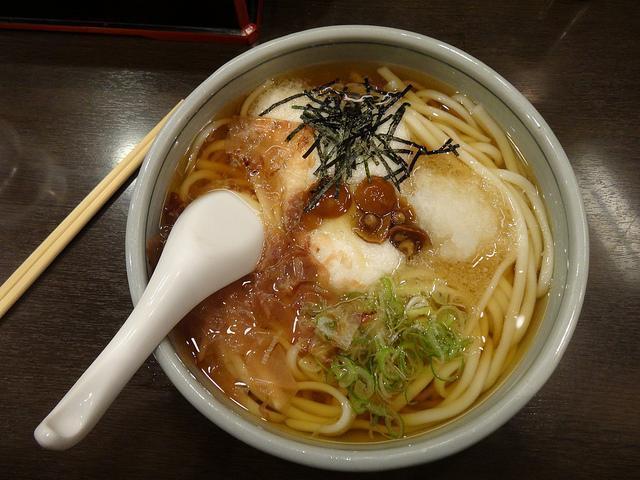What is the bowl made from?
Answer the question by selecting the correct answer among the 4 following choices and explain your choice with a short sentence. The answer should be formatted with the following format: `Answer: choice
Rationale: rationale.`
Options: Wood, steel, plastic, glass. Answer: glass.
Rationale: The bowl the food is in is made from glass. 